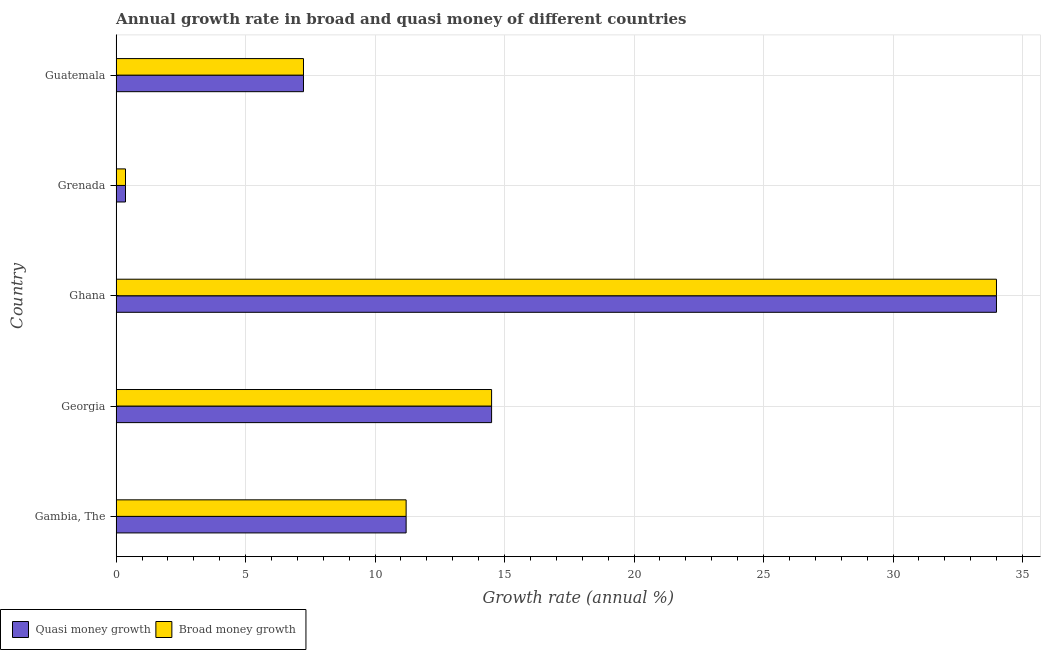How many different coloured bars are there?
Keep it short and to the point. 2. How many bars are there on the 1st tick from the top?
Ensure brevity in your answer.  2. How many bars are there on the 5th tick from the bottom?
Give a very brief answer. 2. What is the label of the 2nd group of bars from the top?
Offer a terse response. Grenada. What is the annual growth rate in quasi money in Guatemala?
Provide a succinct answer. 7.23. Across all countries, what is the maximum annual growth rate in quasi money?
Give a very brief answer. 33.99. Across all countries, what is the minimum annual growth rate in broad money?
Your answer should be compact. 0.36. In which country was the annual growth rate in quasi money minimum?
Provide a succinct answer. Grenada. What is the total annual growth rate in quasi money in the graph?
Make the answer very short. 67.29. What is the difference between the annual growth rate in broad money in Grenada and that in Guatemala?
Ensure brevity in your answer.  -6.87. What is the difference between the annual growth rate in quasi money in Guatemala and the annual growth rate in broad money in Georgia?
Your response must be concise. -7.26. What is the average annual growth rate in quasi money per country?
Give a very brief answer. 13.46. In how many countries, is the annual growth rate in quasi money greater than 9 %?
Keep it short and to the point. 3. What is the ratio of the annual growth rate in broad money in Ghana to that in Grenada?
Keep it short and to the point. 93.92. Is the annual growth rate in broad money in Ghana less than that in Guatemala?
Give a very brief answer. No. Is the difference between the annual growth rate in quasi money in Ghana and Grenada greater than the difference between the annual growth rate in broad money in Ghana and Grenada?
Your response must be concise. No. What is the difference between the highest and the second highest annual growth rate in broad money?
Ensure brevity in your answer.  19.5. What is the difference between the highest and the lowest annual growth rate in broad money?
Keep it short and to the point. 33.63. In how many countries, is the annual growth rate in broad money greater than the average annual growth rate in broad money taken over all countries?
Provide a short and direct response. 2. What does the 2nd bar from the top in Georgia represents?
Provide a succinct answer. Quasi money growth. What does the 2nd bar from the bottom in Georgia represents?
Provide a succinct answer. Broad money growth. Are all the bars in the graph horizontal?
Offer a terse response. Yes. How many countries are there in the graph?
Offer a very short reply. 5. What is the difference between two consecutive major ticks on the X-axis?
Provide a succinct answer. 5. Where does the legend appear in the graph?
Keep it short and to the point. Bottom left. How many legend labels are there?
Provide a short and direct response. 2. How are the legend labels stacked?
Make the answer very short. Horizontal. What is the title of the graph?
Make the answer very short. Annual growth rate in broad and quasi money of different countries. Does "Taxes" appear as one of the legend labels in the graph?
Your answer should be compact. No. What is the label or title of the X-axis?
Ensure brevity in your answer.  Growth rate (annual %). What is the Growth rate (annual %) in Quasi money growth in Gambia, The?
Provide a succinct answer. 11.2. What is the Growth rate (annual %) of Broad money growth in Gambia, The?
Provide a short and direct response. 11.2. What is the Growth rate (annual %) in Quasi money growth in Georgia?
Offer a very short reply. 14.5. What is the Growth rate (annual %) in Broad money growth in Georgia?
Your response must be concise. 14.5. What is the Growth rate (annual %) in Quasi money growth in Ghana?
Offer a very short reply. 33.99. What is the Growth rate (annual %) in Broad money growth in Ghana?
Your answer should be compact. 33.99. What is the Growth rate (annual %) of Quasi money growth in Grenada?
Give a very brief answer. 0.36. What is the Growth rate (annual %) in Broad money growth in Grenada?
Ensure brevity in your answer.  0.36. What is the Growth rate (annual %) of Quasi money growth in Guatemala?
Give a very brief answer. 7.23. What is the Growth rate (annual %) in Broad money growth in Guatemala?
Offer a very short reply. 7.23. Across all countries, what is the maximum Growth rate (annual %) of Quasi money growth?
Your answer should be very brief. 33.99. Across all countries, what is the maximum Growth rate (annual %) in Broad money growth?
Provide a succinct answer. 33.99. Across all countries, what is the minimum Growth rate (annual %) of Quasi money growth?
Your answer should be very brief. 0.36. Across all countries, what is the minimum Growth rate (annual %) in Broad money growth?
Offer a terse response. 0.36. What is the total Growth rate (annual %) in Quasi money growth in the graph?
Provide a short and direct response. 67.29. What is the total Growth rate (annual %) in Broad money growth in the graph?
Offer a very short reply. 67.29. What is the difference between the Growth rate (annual %) in Quasi money growth in Gambia, The and that in Georgia?
Provide a short and direct response. -3.3. What is the difference between the Growth rate (annual %) in Broad money growth in Gambia, The and that in Georgia?
Your answer should be very brief. -3.3. What is the difference between the Growth rate (annual %) of Quasi money growth in Gambia, The and that in Ghana?
Make the answer very short. -22.8. What is the difference between the Growth rate (annual %) of Broad money growth in Gambia, The and that in Ghana?
Offer a terse response. -22.8. What is the difference between the Growth rate (annual %) of Quasi money growth in Gambia, The and that in Grenada?
Your response must be concise. 10.84. What is the difference between the Growth rate (annual %) in Broad money growth in Gambia, The and that in Grenada?
Offer a terse response. 10.84. What is the difference between the Growth rate (annual %) of Quasi money growth in Gambia, The and that in Guatemala?
Ensure brevity in your answer.  3.96. What is the difference between the Growth rate (annual %) of Broad money growth in Gambia, The and that in Guatemala?
Your answer should be compact. 3.96. What is the difference between the Growth rate (annual %) of Quasi money growth in Georgia and that in Ghana?
Keep it short and to the point. -19.5. What is the difference between the Growth rate (annual %) in Broad money growth in Georgia and that in Ghana?
Offer a terse response. -19.5. What is the difference between the Growth rate (annual %) in Quasi money growth in Georgia and that in Grenada?
Your answer should be compact. 14.14. What is the difference between the Growth rate (annual %) in Broad money growth in Georgia and that in Grenada?
Your response must be concise. 14.14. What is the difference between the Growth rate (annual %) of Quasi money growth in Georgia and that in Guatemala?
Your response must be concise. 7.26. What is the difference between the Growth rate (annual %) of Broad money growth in Georgia and that in Guatemala?
Your response must be concise. 7.26. What is the difference between the Growth rate (annual %) in Quasi money growth in Ghana and that in Grenada?
Your answer should be very brief. 33.63. What is the difference between the Growth rate (annual %) in Broad money growth in Ghana and that in Grenada?
Make the answer very short. 33.63. What is the difference between the Growth rate (annual %) in Quasi money growth in Ghana and that in Guatemala?
Ensure brevity in your answer.  26.76. What is the difference between the Growth rate (annual %) in Broad money growth in Ghana and that in Guatemala?
Ensure brevity in your answer.  26.76. What is the difference between the Growth rate (annual %) in Quasi money growth in Grenada and that in Guatemala?
Keep it short and to the point. -6.87. What is the difference between the Growth rate (annual %) of Broad money growth in Grenada and that in Guatemala?
Make the answer very short. -6.87. What is the difference between the Growth rate (annual %) of Quasi money growth in Gambia, The and the Growth rate (annual %) of Broad money growth in Georgia?
Provide a succinct answer. -3.3. What is the difference between the Growth rate (annual %) in Quasi money growth in Gambia, The and the Growth rate (annual %) in Broad money growth in Ghana?
Make the answer very short. -22.8. What is the difference between the Growth rate (annual %) in Quasi money growth in Gambia, The and the Growth rate (annual %) in Broad money growth in Grenada?
Your answer should be very brief. 10.84. What is the difference between the Growth rate (annual %) in Quasi money growth in Gambia, The and the Growth rate (annual %) in Broad money growth in Guatemala?
Provide a short and direct response. 3.96. What is the difference between the Growth rate (annual %) of Quasi money growth in Georgia and the Growth rate (annual %) of Broad money growth in Ghana?
Ensure brevity in your answer.  -19.5. What is the difference between the Growth rate (annual %) of Quasi money growth in Georgia and the Growth rate (annual %) of Broad money growth in Grenada?
Offer a terse response. 14.14. What is the difference between the Growth rate (annual %) in Quasi money growth in Georgia and the Growth rate (annual %) in Broad money growth in Guatemala?
Provide a short and direct response. 7.26. What is the difference between the Growth rate (annual %) in Quasi money growth in Ghana and the Growth rate (annual %) in Broad money growth in Grenada?
Your answer should be very brief. 33.63. What is the difference between the Growth rate (annual %) in Quasi money growth in Ghana and the Growth rate (annual %) in Broad money growth in Guatemala?
Your answer should be very brief. 26.76. What is the difference between the Growth rate (annual %) of Quasi money growth in Grenada and the Growth rate (annual %) of Broad money growth in Guatemala?
Offer a terse response. -6.87. What is the average Growth rate (annual %) of Quasi money growth per country?
Provide a succinct answer. 13.46. What is the average Growth rate (annual %) of Broad money growth per country?
Your response must be concise. 13.46. What is the difference between the Growth rate (annual %) of Quasi money growth and Growth rate (annual %) of Broad money growth in Grenada?
Your response must be concise. 0. What is the difference between the Growth rate (annual %) of Quasi money growth and Growth rate (annual %) of Broad money growth in Guatemala?
Keep it short and to the point. 0. What is the ratio of the Growth rate (annual %) of Quasi money growth in Gambia, The to that in Georgia?
Give a very brief answer. 0.77. What is the ratio of the Growth rate (annual %) in Broad money growth in Gambia, The to that in Georgia?
Your answer should be very brief. 0.77. What is the ratio of the Growth rate (annual %) of Quasi money growth in Gambia, The to that in Ghana?
Offer a very short reply. 0.33. What is the ratio of the Growth rate (annual %) of Broad money growth in Gambia, The to that in Ghana?
Offer a terse response. 0.33. What is the ratio of the Growth rate (annual %) of Quasi money growth in Gambia, The to that in Grenada?
Keep it short and to the point. 30.94. What is the ratio of the Growth rate (annual %) in Broad money growth in Gambia, The to that in Grenada?
Keep it short and to the point. 30.94. What is the ratio of the Growth rate (annual %) in Quasi money growth in Gambia, The to that in Guatemala?
Offer a terse response. 1.55. What is the ratio of the Growth rate (annual %) of Broad money growth in Gambia, The to that in Guatemala?
Offer a terse response. 1.55. What is the ratio of the Growth rate (annual %) of Quasi money growth in Georgia to that in Ghana?
Provide a short and direct response. 0.43. What is the ratio of the Growth rate (annual %) of Broad money growth in Georgia to that in Ghana?
Give a very brief answer. 0.43. What is the ratio of the Growth rate (annual %) in Quasi money growth in Georgia to that in Grenada?
Offer a very short reply. 40.06. What is the ratio of the Growth rate (annual %) in Broad money growth in Georgia to that in Grenada?
Provide a short and direct response. 40.06. What is the ratio of the Growth rate (annual %) in Quasi money growth in Georgia to that in Guatemala?
Give a very brief answer. 2. What is the ratio of the Growth rate (annual %) in Broad money growth in Georgia to that in Guatemala?
Keep it short and to the point. 2. What is the ratio of the Growth rate (annual %) of Quasi money growth in Ghana to that in Grenada?
Offer a very short reply. 93.92. What is the ratio of the Growth rate (annual %) of Broad money growth in Ghana to that in Grenada?
Your answer should be very brief. 93.92. What is the ratio of the Growth rate (annual %) in Quasi money growth in Ghana to that in Guatemala?
Provide a short and direct response. 4.7. What is the ratio of the Growth rate (annual %) in Broad money growth in Ghana to that in Guatemala?
Give a very brief answer. 4.7. What is the difference between the highest and the second highest Growth rate (annual %) of Quasi money growth?
Provide a succinct answer. 19.5. What is the difference between the highest and the second highest Growth rate (annual %) of Broad money growth?
Provide a short and direct response. 19.5. What is the difference between the highest and the lowest Growth rate (annual %) of Quasi money growth?
Make the answer very short. 33.63. What is the difference between the highest and the lowest Growth rate (annual %) of Broad money growth?
Offer a very short reply. 33.63. 